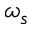Convert formula to latex. <formula><loc_0><loc_0><loc_500><loc_500>\omega _ { s }</formula> 